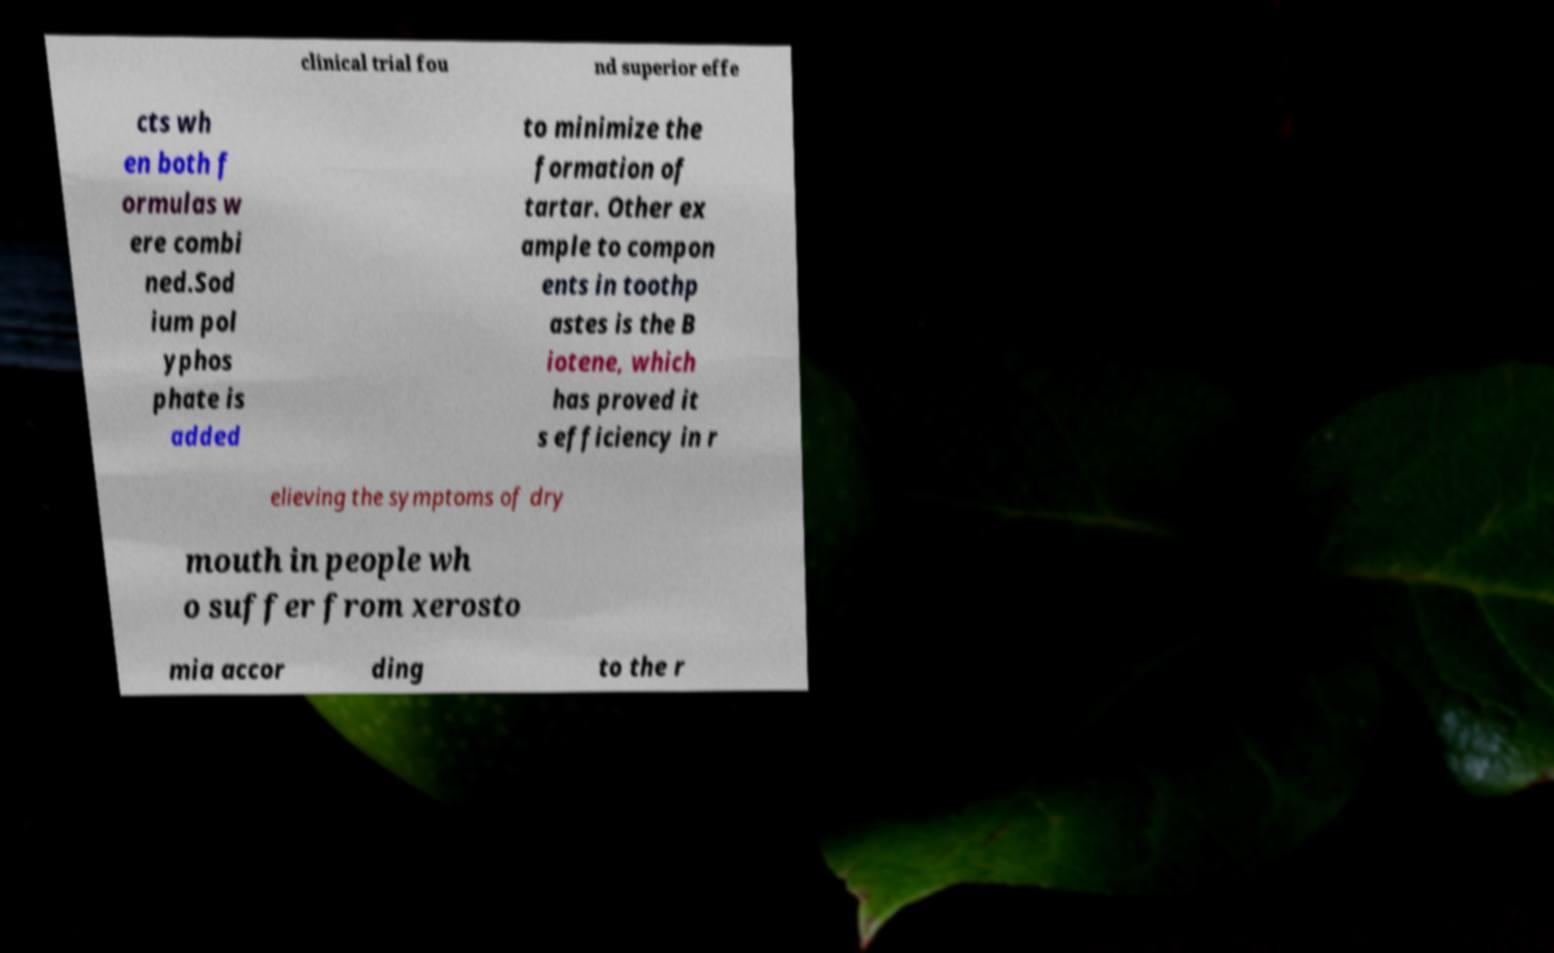I need the written content from this picture converted into text. Can you do that? clinical trial fou nd superior effe cts wh en both f ormulas w ere combi ned.Sod ium pol yphos phate is added to minimize the formation of tartar. Other ex ample to compon ents in toothp astes is the B iotene, which has proved it s efficiency in r elieving the symptoms of dry mouth in people wh o suffer from xerosto mia accor ding to the r 